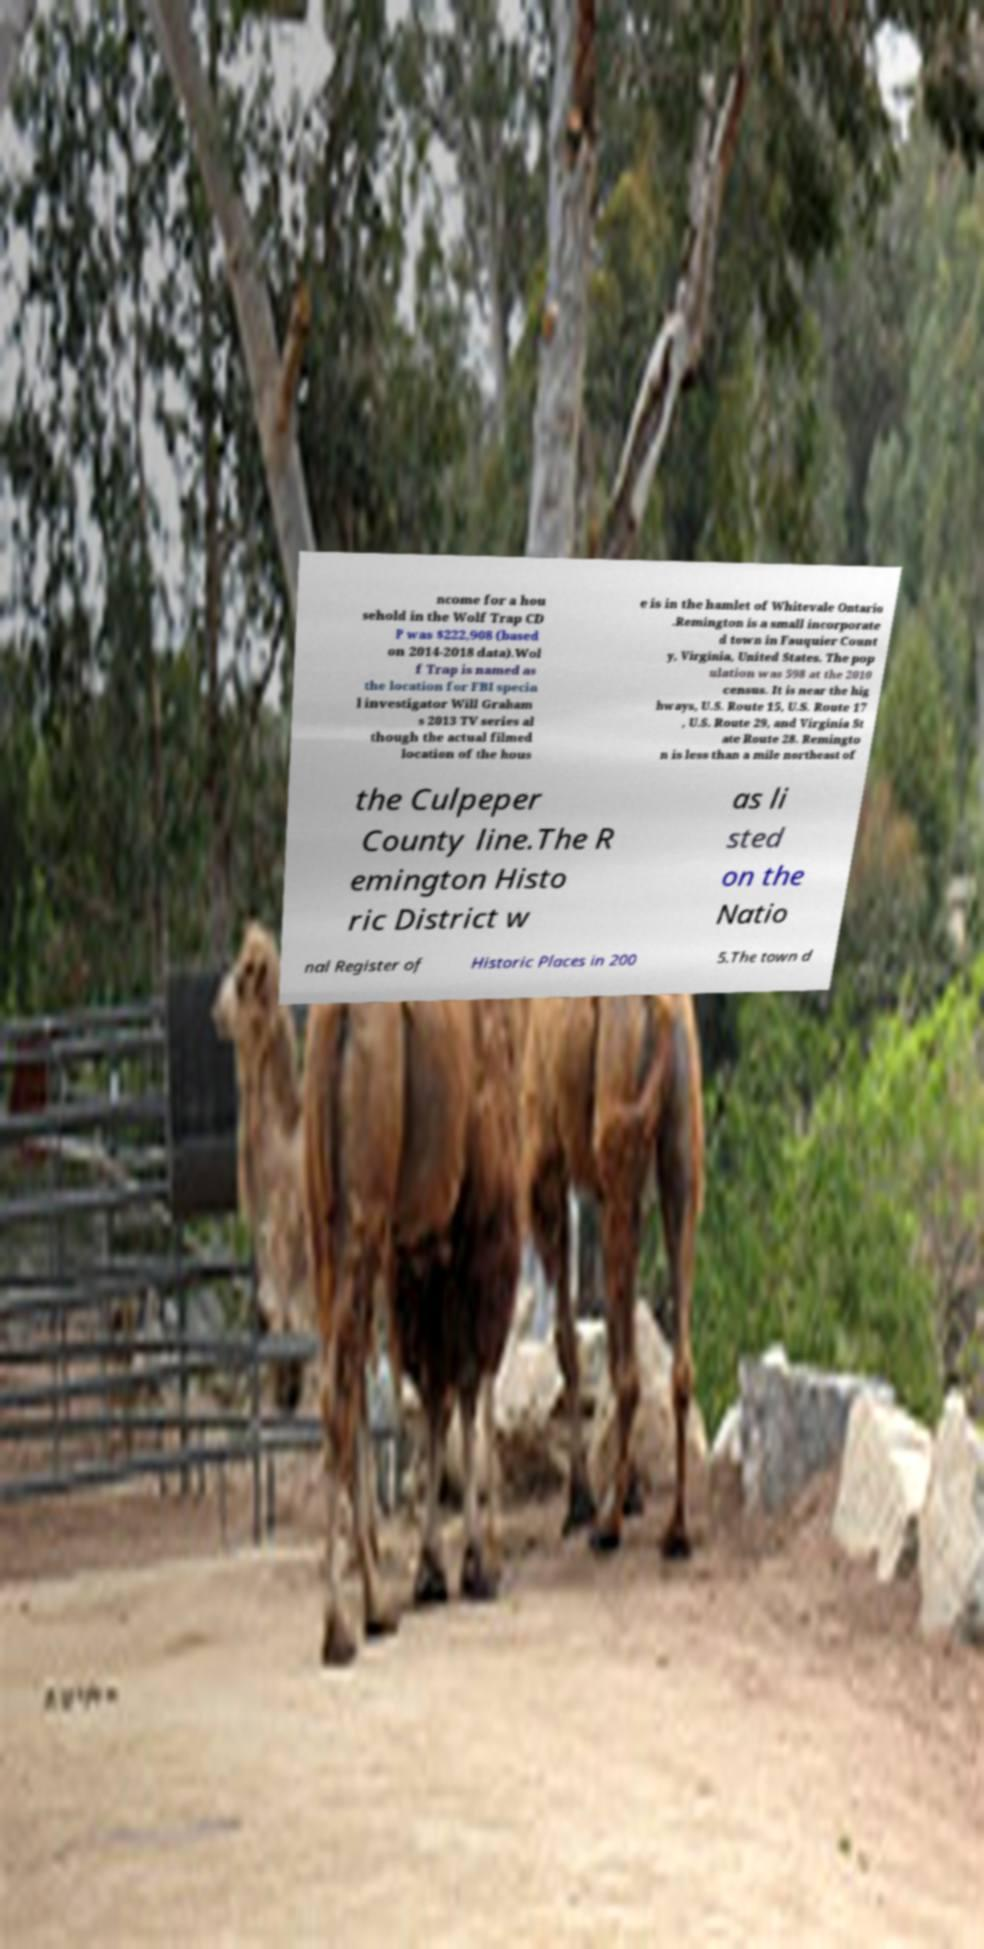Please read and relay the text visible in this image. What does it say? ncome for a hou sehold in the Wolf Trap CD P was $222,908 (based on 2014-2018 data).Wol f Trap is named as the location for FBI specia l investigator Will Graham s 2013 TV series al though the actual filmed location of the hous e is in the hamlet of Whitevale Ontario .Remington is a small incorporate d town in Fauquier Count y, Virginia, United States. The pop ulation was 598 at the 2010 census. It is near the hig hways, U.S. Route 15, U.S. Route 17 , U.S. Route 29, and Virginia St ate Route 28. Remingto n is less than a mile northeast of the Culpeper County line.The R emington Histo ric District w as li sted on the Natio nal Register of Historic Places in 200 5.The town d 